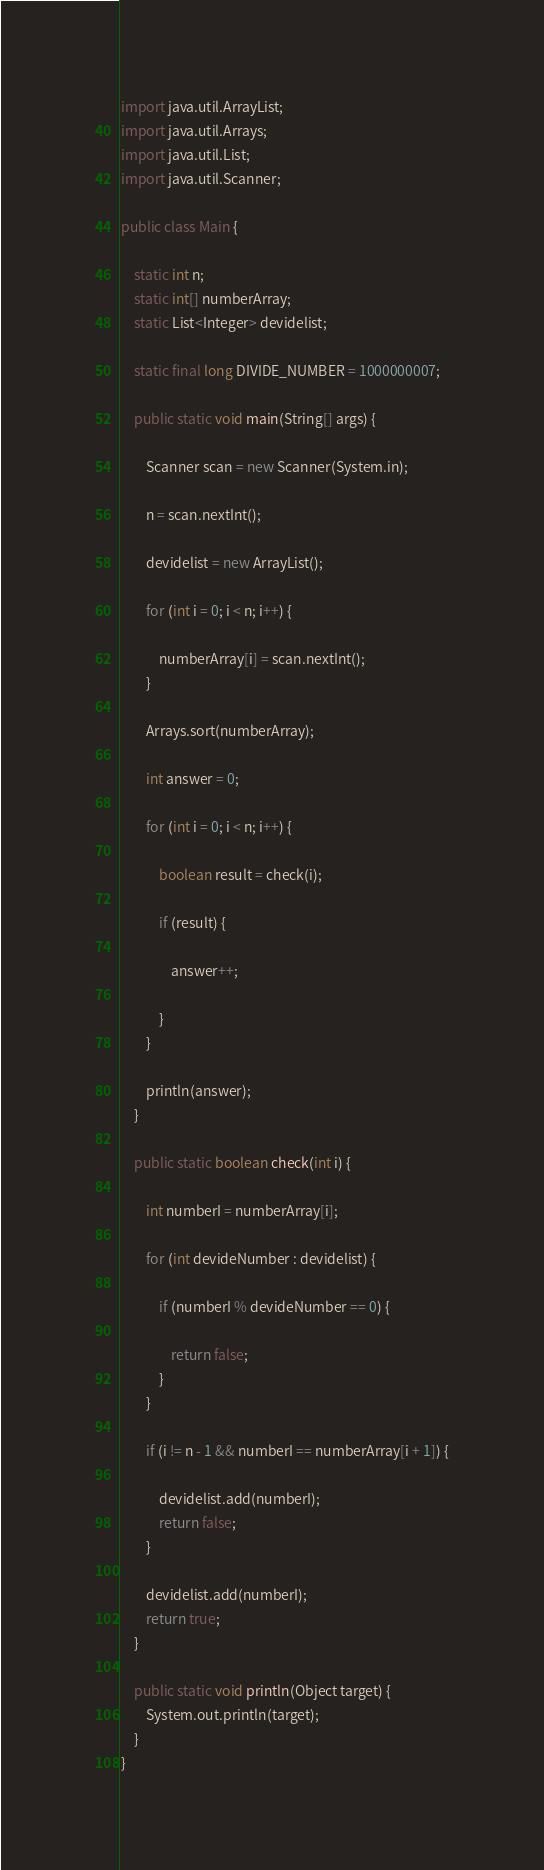<code> <loc_0><loc_0><loc_500><loc_500><_Java_>import java.util.ArrayList;
import java.util.Arrays;
import java.util.List;
import java.util.Scanner;

public class Main {

	static int n;
	static int[] numberArray;
	static List<Integer> devidelist;

	static final long DIVIDE_NUMBER = 1000000007;

	public static void main(String[] args) {

		Scanner scan = new Scanner(System.in);

		n = scan.nextInt();

		devidelist = new ArrayList();

		for (int i = 0; i < n; i++) {

			numberArray[i] = scan.nextInt();
		}

		Arrays.sort(numberArray);

		int answer = 0;

		for (int i = 0; i < n; i++) {

			boolean result = check(i);

			if (result) {

				answer++;

			}
		}

		println(answer);
	}

	public static boolean check(int i) {

		int numberI = numberArray[i];

		for (int devideNumber : devidelist) {

			if (numberI % devideNumber == 0) {

				return false;
			}
		}

		if (i != n - 1 && numberI == numberArray[i + 1]) {

			devidelist.add(numberI);
			return false;
		}

		devidelist.add(numberI);
		return true;
	}

	public static void println(Object target) {
		System.out.println(target);
	}
}
</code> 